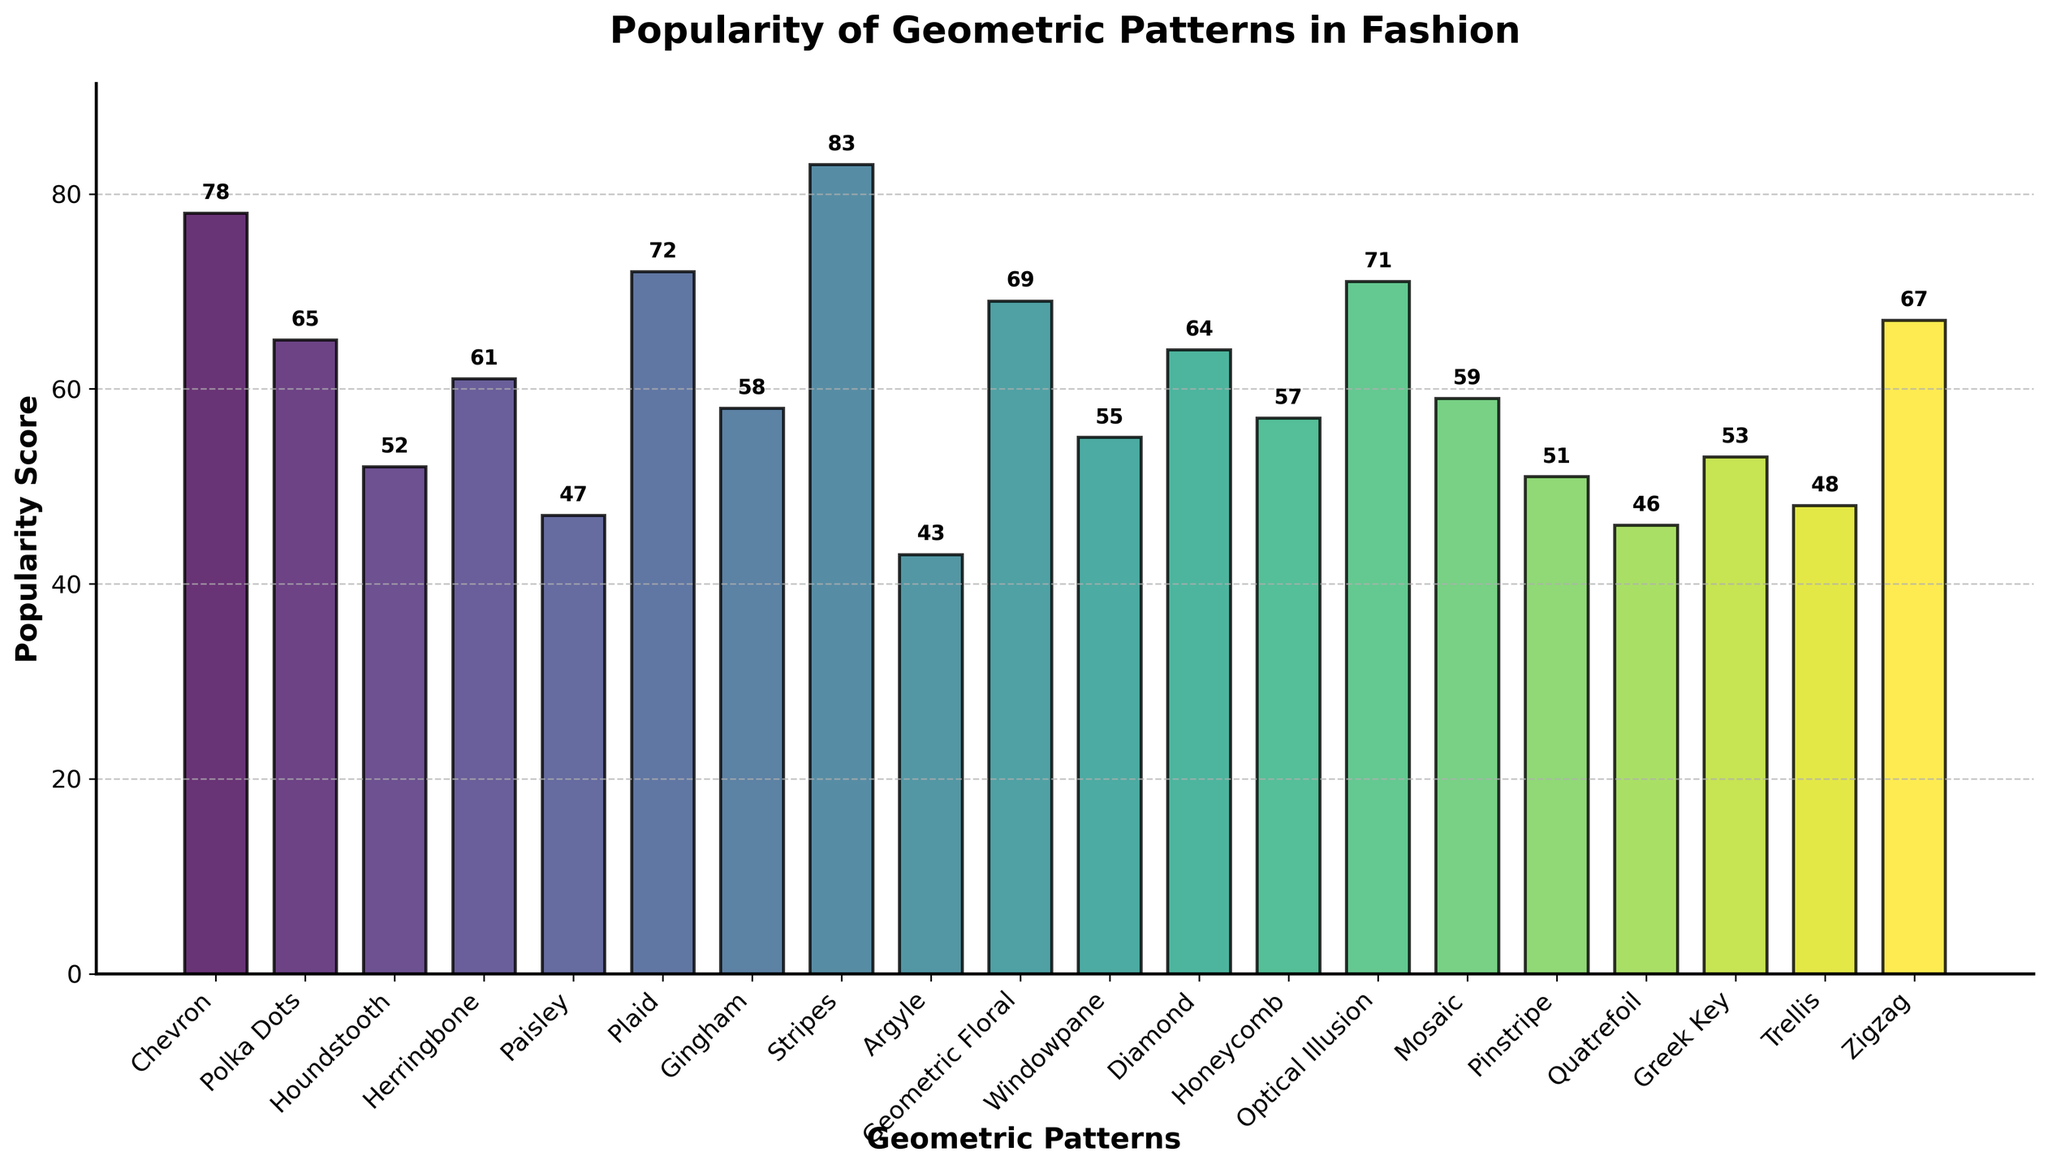Which geometric pattern has the highest popularity score? To find the geometric pattern with the highest popularity score, look for the tallest bar on the chart. The tallest bar represents the pattern with the score of 83, which is Stripes.
Answer: Stripes Which geometric pattern is more popular, Polka Dots or Paisley? To determine which pattern is more popular, compare the height of their respective bars. Polka Dots has a popularity score of 65, whereas Paisley has a score of 47. Therefore, Polka Dots is more popular.
Answer: Polka Dots What is the average popularity score of Chevron, Plaid, and Optical Illusion? First, identify the popularity scores of Chevron (78), Plaid (72), and Optical Illusion (71). Then, add these scores (78 + 72 + 71 = 221) and divide by the number of patterns (221 / 3 = 73.67).
Answer: 73.67 Which pattern has the closest popularity score to the median popularity score of all patterns listed? To find the median, first list all popularity scores in ascending order: 43, 46, 47, 48, 51, 52, 53, 55, 57, 58, 59, 61, 64, 65, 67, 69, 71, 72, 78, 83. The median is the middle number, which is 59 (average of 10th and 11th scores). The pattern with a popularity score of 59 is Mosaic.
Answer: Mosaic Is the popularity score of Houndstooth higher or lower than the average popularity score of all patterns? First, compute the average popularity score: (78 + 65 + 52 + 61 + 47 + 72 + 58 + 83 + 43 + 69 + 55 + 64 + 57 + 71 + 59 + 51 + 46 + 53 + 48 + 67) / 20 = 60.1. Houndstooth has a score of 52, which is lower than the average score of 60.1.
Answer: Lower How many patterns have a popularity score greater than 60? Identify patterns with scores above 60: Chevron (78), Plaid (72), Stripes (83), Polka Dots (65), Herringbone (61), Diamond (64), Optical Illusion (71), Geometric Floral (69), Zigzag (67). There are 9 patterns with scores greater than 60.
Answer: 9 What is the difference in popularity scores between Gingham and Windowpane? Gingham has a popularity score of 58 and Windowpane has a score of 55. The difference is 58 - 55 = 3.
Answer: 3 Which patterns have popularity scores closest to the average popularity score of all patterns? Calculate the average popularity score: 60.1. Then compare each score to 60.1. Patterns with scores closest to 60.1 are Herringbone (61), Diamond (64), Honeycomb (57), Gingham (58).
Answer: Herringbone, Diamond, Honeycomb, Gingham What is the sum of popularity scores for the least popular and the most popular patterns? The least popular pattern is Argyle with a score of 43, and the most popular pattern is Stripes with a score of 83. Summing these scores gives 43 + 83 = 126.
Answer: 126 Which patterns have a popularity score less than 50? Identify patterns with scores below 50: Paisley (47), Argyle (43), Quatrefoil (46), Trellis (48), Pinstripe (51).
Answer: Paisley, Argyle, Quatrefoil, Trellis 